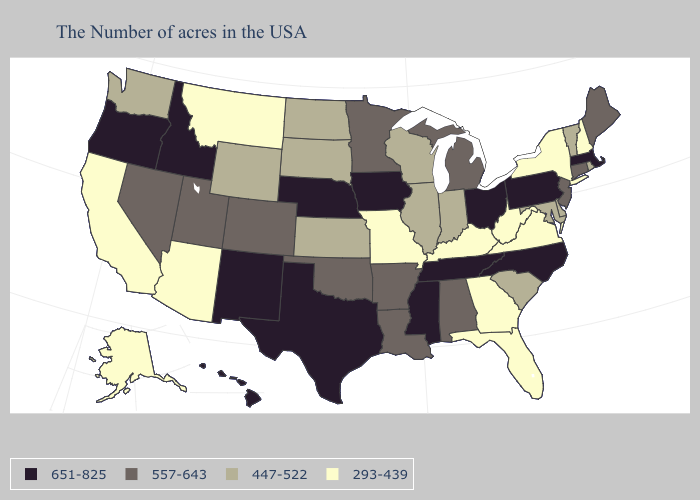Name the states that have a value in the range 557-643?
Be succinct. Maine, Connecticut, New Jersey, Michigan, Alabama, Louisiana, Arkansas, Minnesota, Oklahoma, Colorado, Utah, Nevada. Name the states that have a value in the range 447-522?
Short answer required. Rhode Island, Vermont, Delaware, Maryland, South Carolina, Indiana, Wisconsin, Illinois, Kansas, South Dakota, North Dakota, Wyoming, Washington. Does Massachusetts have a higher value than Idaho?
Write a very short answer. No. What is the value of Kentucky?
Answer briefly. 293-439. Does the map have missing data?
Short answer required. No. What is the value of Wyoming?
Concise answer only. 447-522. What is the value of Vermont?
Short answer required. 447-522. Does Illinois have the same value as Colorado?
Quick response, please. No. Name the states that have a value in the range 447-522?
Give a very brief answer. Rhode Island, Vermont, Delaware, Maryland, South Carolina, Indiana, Wisconsin, Illinois, Kansas, South Dakota, North Dakota, Wyoming, Washington. Which states have the lowest value in the Northeast?
Answer briefly. New Hampshire, New York. Name the states that have a value in the range 293-439?
Be succinct. New Hampshire, New York, Virginia, West Virginia, Florida, Georgia, Kentucky, Missouri, Montana, Arizona, California, Alaska. Name the states that have a value in the range 293-439?
Be succinct. New Hampshire, New York, Virginia, West Virginia, Florida, Georgia, Kentucky, Missouri, Montana, Arizona, California, Alaska. Name the states that have a value in the range 557-643?
Give a very brief answer. Maine, Connecticut, New Jersey, Michigan, Alabama, Louisiana, Arkansas, Minnesota, Oklahoma, Colorado, Utah, Nevada. Does Colorado have the lowest value in the USA?
Answer briefly. No. Which states have the lowest value in the USA?
Give a very brief answer. New Hampshire, New York, Virginia, West Virginia, Florida, Georgia, Kentucky, Missouri, Montana, Arizona, California, Alaska. 